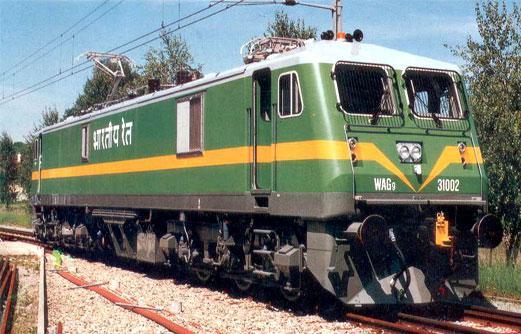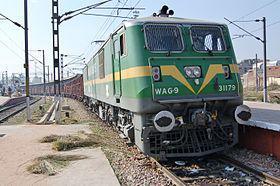The first image is the image on the left, the second image is the image on the right. Considering the images on both sides, is "The image on the right contains a green and yellow train." valid? Answer yes or no. Yes. 